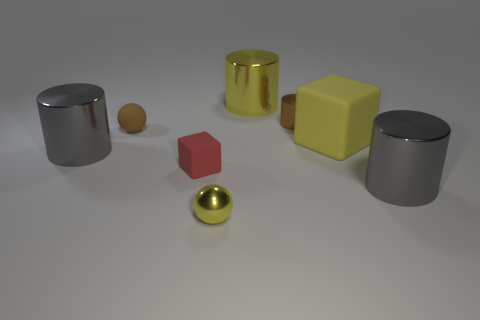Add 1 big yellow cylinders. How many objects exist? 9 Subtract all balls. How many objects are left? 6 Subtract all big yellow rubber cubes. Subtract all small brown rubber things. How many objects are left? 6 Add 8 big yellow matte cubes. How many big yellow matte cubes are left? 9 Add 5 large rubber blocks. How many large rubber blocks exist? 6 Subtract 0 red cylinders. How many objects are left? 8 